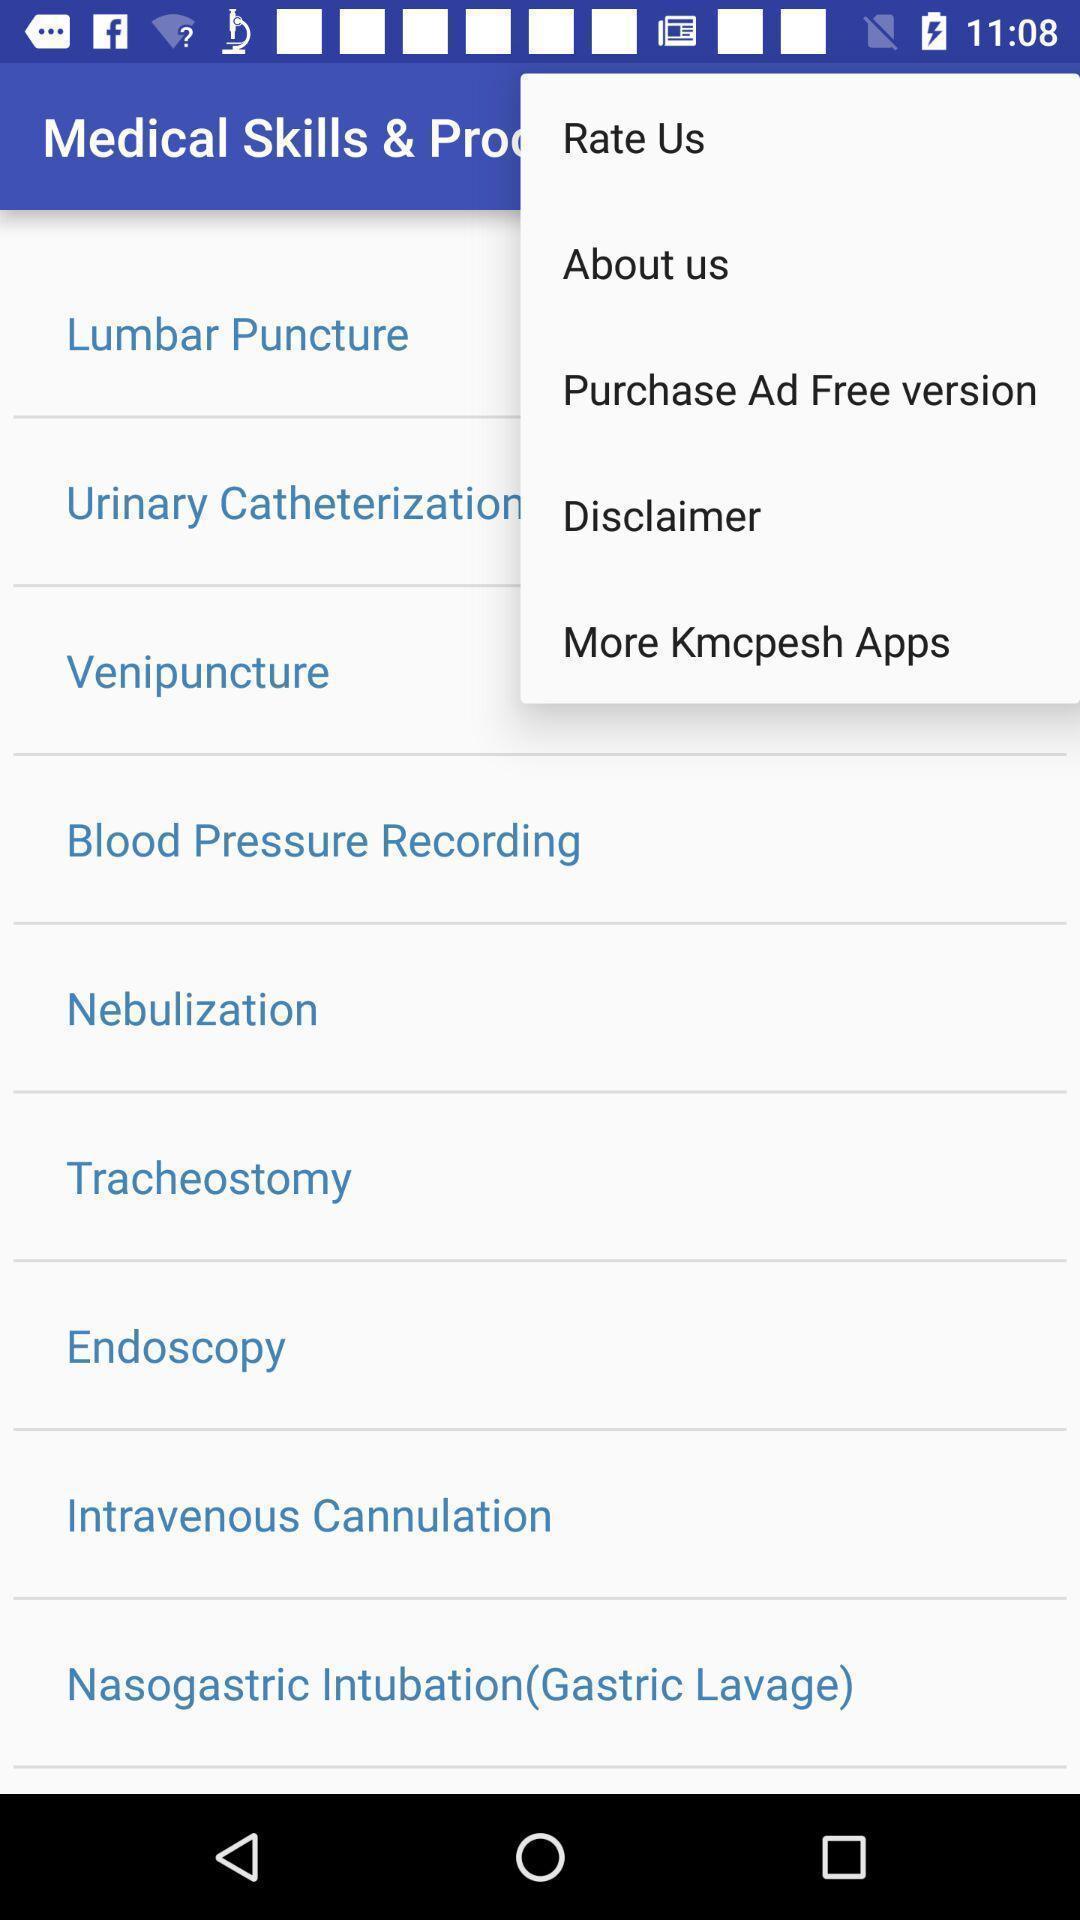What can you discern from this picture? Page displays options in medical app. 